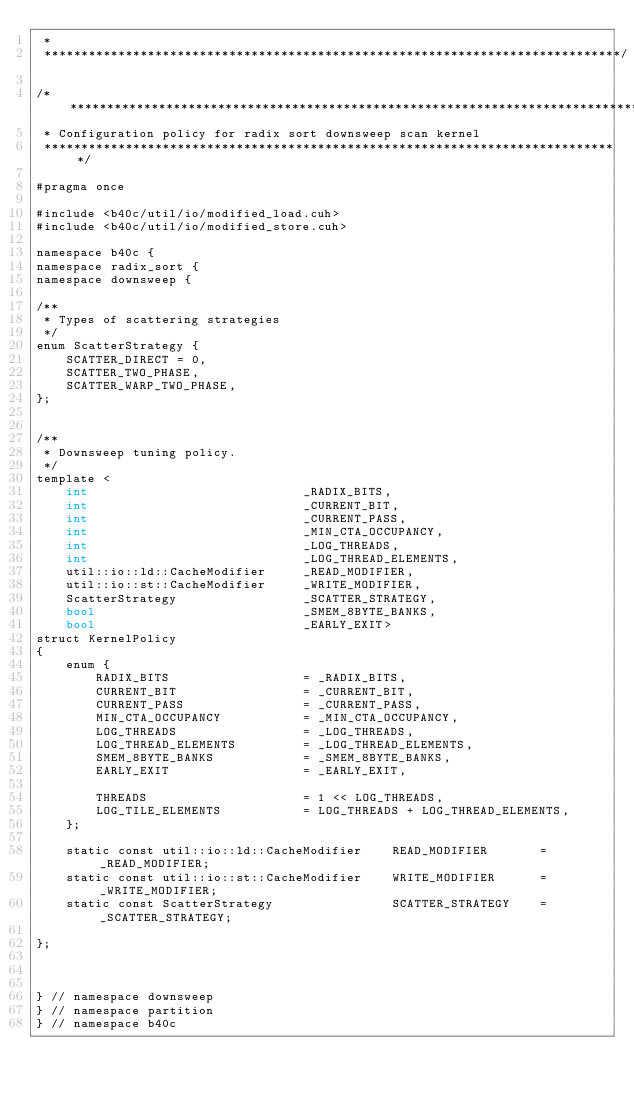Convert code to text. <code><loc_0><loc_0><loc_500><loc_500><_Cuda_> * 
 ******************************************************************************/

/******************************************************************************
 * Configuration policy for radix sort downsweep scan kernel
 ******************************************************************************/

#pragma once

#include <b40c/util/io/modified_load.cuh>
#include <b40c/util/io/modified_store.cuh>

namespace b40c {
namespace radix_sort {
namespace downsweep {

/**
 * Types of scattering strategies
 */
enum ScatterStrategy {
	SCATTER_DIRECT = 0,
	SCATTER_TWO_PHASE,
	SCATTER_WARP_TWO_PHASE,
};


/**
 * Downsweep tuning policy.
 */
template <
	int 							_RADIX_BITS,
	int 							_CURRENT_BIT,
	int 							_CURRENT_PASS,
	int 							_MIN_CTA_OCCUPANCY,
	int 							_LOG_THREADS,
	int 							_LOG_THREAD_ELEMENTS,
	util::io::ld::CacheModifier	 	_READ_MODIFIER,
	util::io::st::CacheModifier 	_WRITE_MODIFIER,
	ScatterStrategy 				_SCATTER_STRATEGY,
	bool							_SMEM_8BYTE_BANKS,
	bool						 	_EARLY_EXIT>
struct KernelPolicy
{
	enum {
		RADIX_BITS					= _RADIX_BITS,
		CURRENT_BIT 				= _CURRENT_BIT,
		CURRENT_PASS 				= _CURRENT_PASS,
		MIN_CTA_OCCUPANCY  			= _MIN_CTA_OCCUPANCY,
		LOG_THREADS 				= _LOG_THREADS,
		LOG_THREAD_ELEMENTS 		= _LOG_THREAD_ELEMENTS,
		SMEM_8BYTE_BANKS			= _SMEM_8BYTE_BANKS,
		EARLY_EXIT					= _EARLY_EXIT,

		THREADS						= 1 << LOG_THREADS,
		LOG_TILE_ELEMENTS			= LOG_THREADS + LOG_THREAD_ELEMENTS,
	};

	static const util::io::ld::CacheModifier 	READ_MODIFIER 		= _READ_MODIFIER;
	static const util::io::st::CacheModifier 	WRITE_MODIFIER 		= _WRITE_MODIFIER;
	static const ScatterStrategy 				SCATTER_STRATEGY 	= _SCATTER_STRATEGY;

};



} // namespace downsweep
} // namespace partition
} // namespace b40c

</code> 